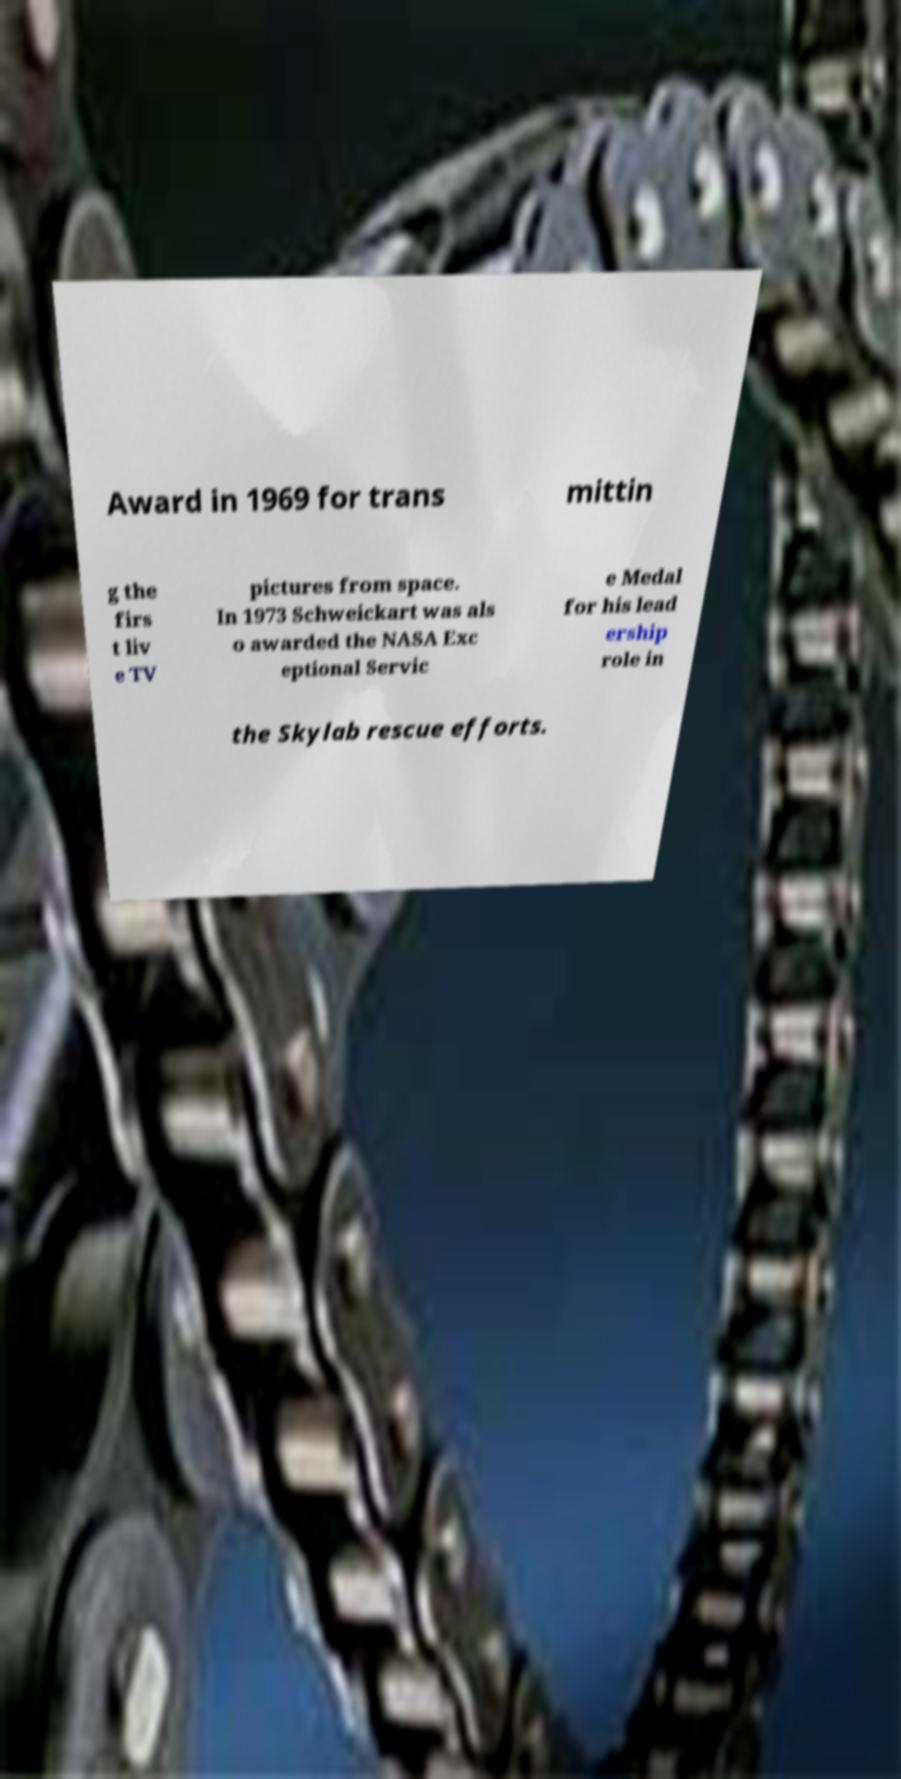Could you extract and type out the text from this image? Award in 1969 for trans mittin g the firs t liv e TV pictures from space. In 1973 Schweickart was als o awarded the NASA Exc eptional Servic e Medal for his lead ership role in the Skylab rescue efforts. 